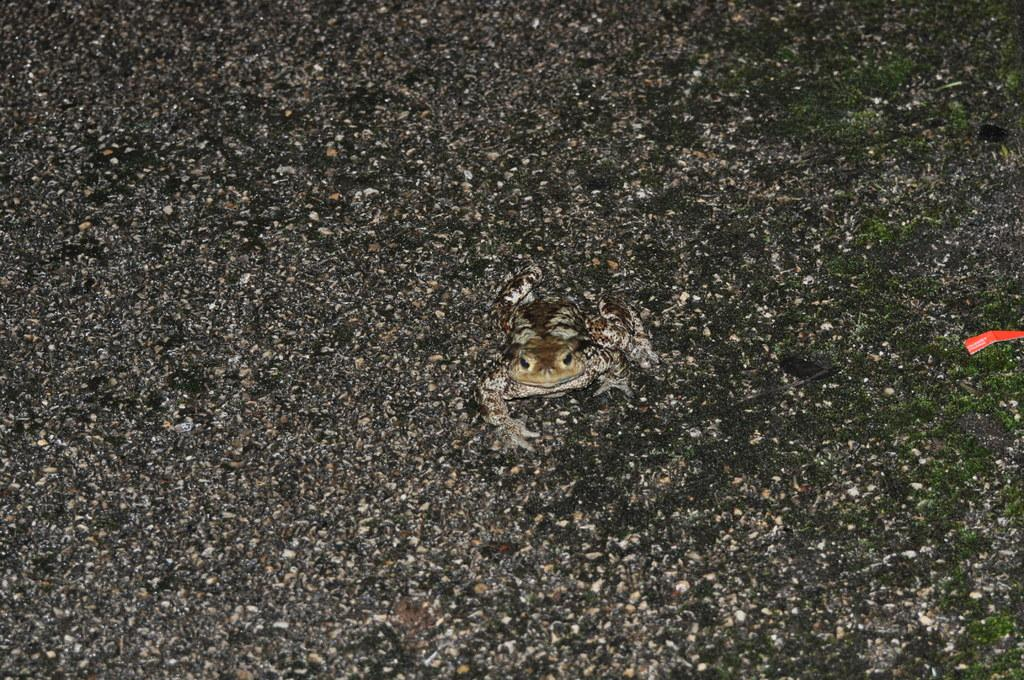What type of animal is in the image? There is an eastern spadefoot in the image. Where is the eastern spadefoot located in the image? The eastern spadefoot is in the middle of the image. What can be seen at the bottom of the image? There are stones at the bottom of the image. What type of vegetation is present in the image? There is grass in the image. What type of smell can be detected from the eastern spadefoot in the image? There is no indication of smell in the image, as it is a visual medium. 